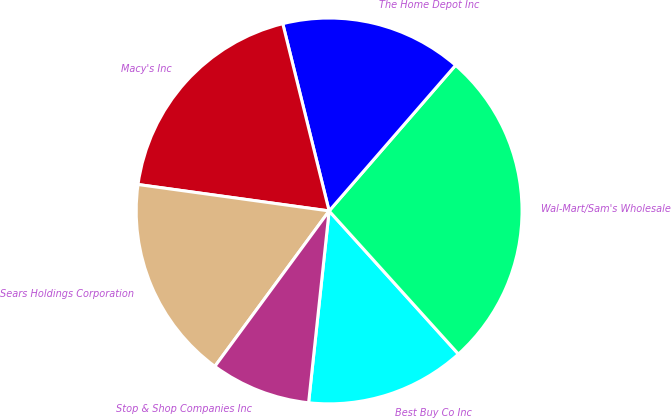<chart> <loc_0><loc_0><loc_500><loc_500><pie_chart><fcel>Best Buy Co Inc<fcel>Wal-Mart/Sam's Wholesale<fcel>The Home Depot Inc<fcel>Macy's Inc<fcel>Sears Holdings Corporation<fcel>Stop & Shop Companies Inc<nl><fcel>13.39%<fcel>26.93%<fcel>15.24%<fcel>18.95%<fcel>17.1%<fcel>8.39%<nl></chart> 